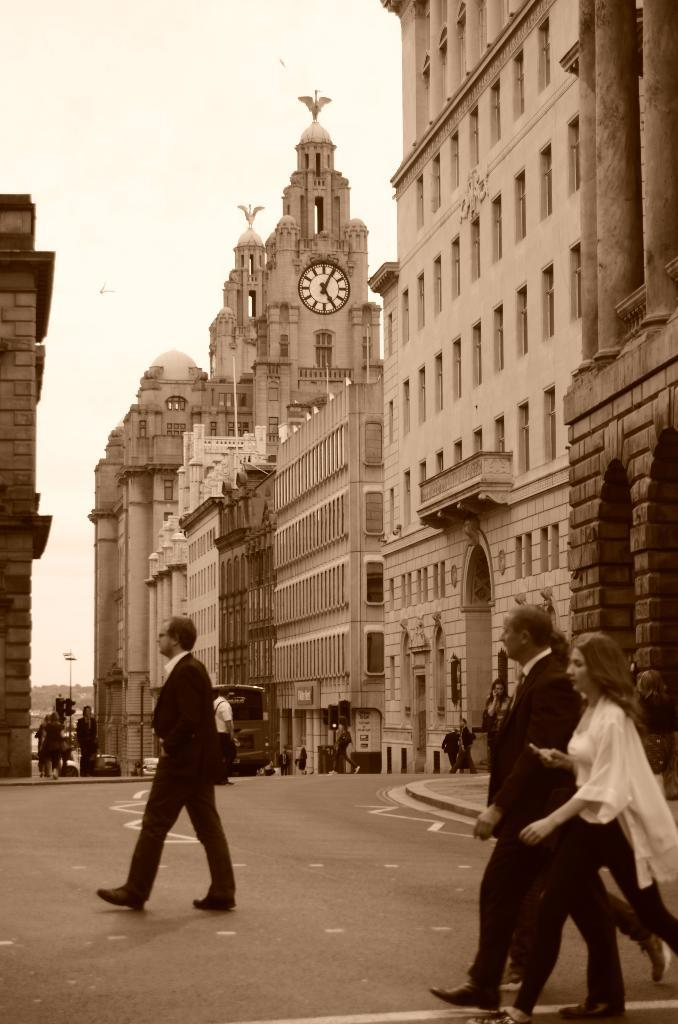What can be seen moving in the image? There are vehicles in the image, and people are walking on the road. What type of structures are visible in the background? There are buildings in the background of the image. What type of owl can be seen sitting on the roof of the building in the image? There is no owl present in the image; only vehicles, people walking, and buildings are visible. 